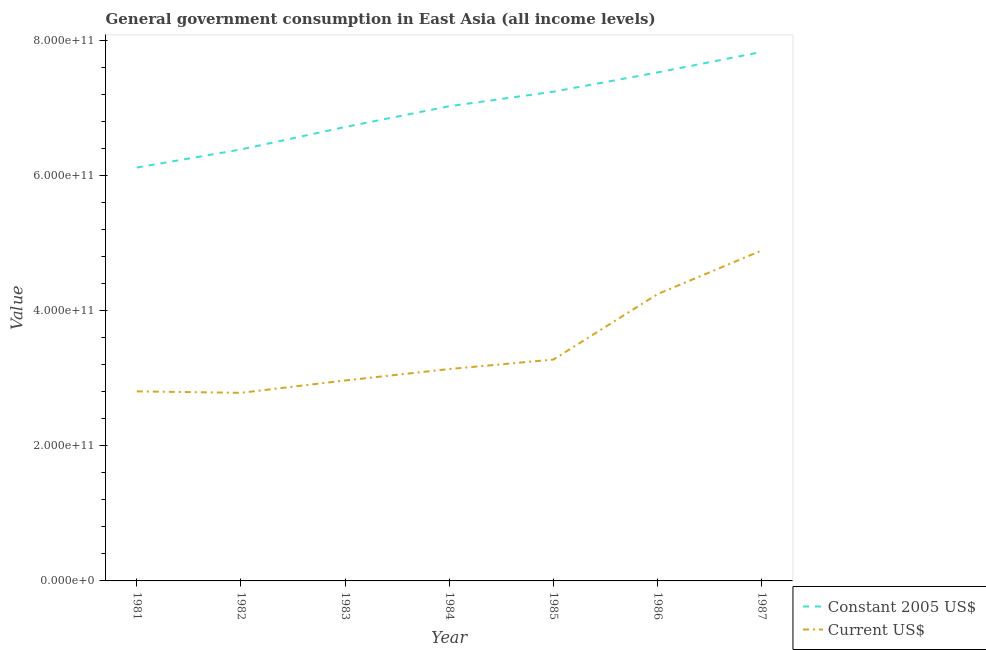How many different coloured lines are there?
Your response must be concise. 2. Does the line corresponding to value consumed in current us$ intersect with the line corresponding to value consumed in constant 2005 us$?
Keep it short and to the point. No. Is the number of lines equal to the number of legend labels?
Your response must be concise. Yes. What is the value consumed in current us$ in 1984?
Provide a short and direct response. 3.13e+11. Across all years, what is the maximum value consumed in current us$?
Offer a very short reply. 4.89e+11. Across all years, what is the minimum value consumed in constant 2005 us$?
Your answer should be very brief. 6.11e+11. What is the total value consumed in constant 2005 us$ in the graph?
Provide a succinct answer. 4.88e+12. What is the difference between the value consumed in current us$ in 1984 and that in 1986?
Your response must be concise. -1.11e+11. What is the difference between the value consumed in current us$ in 1985 and the value consumed in constant 2005 us$ in 1984?
Provide a succinct answer. -3.75e+11. What is the average value consumed in constant 2005 us$ per year?
Your response must be concise. 6.97e+11. In the year 1985, what is the difference between the value consumed in constant 2005 us$ and value consumed in current us$?
Your response must be concise. 3.96e+11. In how many years, is the value consumed in constant 2005 us$ greater than 240000000000?
Offer a very short reply. 7. What is the ratio of the value consumed in current us$ in 1985 to that in 1986?
Offer a very short reply. 0.77. Is the difference between the value consumed in constant 2005 us$ in 1985 and 1986 greater than the difference between the value consumed in current us$ in 1985 and 1986?
Make the answer very short. Yes. What is the difference between the highest and the second highest value consumed in current us$?
Offer a terse response. 6.45e+1. What is the difference between the highest and the lowest value consumed in current us$?
Offer a very short reply. 2.11e+11. In how many years, is the value consumed in current us$ greater than the average value consumed in current us$ taken over all years?
Your answer should be very brief. 2. Is the sum of the value consumed in constant 2005 us$ in 1984 and 1985 greater than the maximum value consumed in current us$ across all years?
Offer a very short reply. Yes. How many years are there in the graph?
Your response must be concise. 7. What is the difference between two consecutive major ticks on the Y-axis?
Make the answer very short. 2.00e+11. Are the values on the major ticks of Y-axis written in scientific E-notation?
Offer a very short reply. Yes. Does the graph contain grids?
Offer a very short reply. No. Where does the legend appear in the graph?
Your answer should be compact. Bottom right. What is the title of the graph?
Keep it short and to the point. General government consumption in East Asia (all income levels). What is the label or title of the Y-axis?
Your response must be concise. Value. What is the Value of Constant 2005 US$ in 1981?
Give a very brief answer. 6.11e+11. What is the Value in Current US$ in 1981?
Your response must be concise. 2.80e+11. What is the Value in Constant 2005 US$ in 1982?
Ensure brevity in your answer.  6.38e+11. What is the Value of Current US$ in 1982?
Give a very brief answer. 2.78e+11. What is the Value of Constant 2005 US$ in 1983?
Ensure brevity in your answer.  6.71e+11. What is the Value of Current US$ in 1983?
Provide a succinct answer. 2.96e+11. What is the Value of Constant 2005 US$ in 1984?
Your response must be concise. 7.02e+11. What is the Value in Current US$ in 1984?
Provide a short and direct response. 3.13e+11. What is the Value of Constant 2005 US$ in 1985?
Offer a very short reply. 7.24e+11. What is the Value in Current US$ in 1985?
Make the answer very short. 3.27e+11. What is the Value in Constant 2005 US$ in 1986?
Provide a short and direct response. 7.52e+11. What is the Value of Current US$ in 1986?
Give a very brief answer. 4.24e+11. What is the Value of Constant 2005 US$ in 1987?
Your answer should be very brief. 7.83e+11. What is the Value in Current US$ in 1987?
Ensure brevity in your answer.  4.89e+11. Across all years, what is the maximum Value in Constant 2005 US$?
Provide a short and direct response. 7.83e+11. Across all years, what is the maximum Value of Current US$?
Provide a short and direct response. 4.89e+11. Across all years, what is the minimum Value of Constant 2005 US$?
Your answer should be very brief. 6.11e+11. Across all years, what is the minimum Value in Current US$?
Provide a succinct answer. 2.78e+11. What is the total Value in Constant 2005 US$ in the graph?
Your response must be concise. 4.88e+12. What is the total Value of Current US$ in the graph?
Give a very brief answer. 2.41e+12. What is the difference between the Value of Constant 2005 US$ in 1981 and that in 1982?
Offer a terse response. -2.68e+1. What is the difference between the Value of Current US$ in 1981 and that in 1982?
Provide a succinct answer. 2.12e+09. What is the difference between the Value in Constant 2005 US$ in 1981 and that in 1983?
Provide a short and direct response. -6.00e+1. What is the difference between the Value of Current US$ in 1981 and that in 1983?
Ensure brevity in your answer.  -1.61e+1. What is the difference between the Value of Constant 2005 US$ in 1981 and that in 1984?
Your answer should be very brief. -9.08e+1. What is the difference between the Value of Current US$ in 1981 and that in 1984?
Your response must be concise. -3.31e+1. What is the difference between the Value in Constant 2005 US$ in 1981 and that in 1985?
Keep it short and to the point. -1.12e+11. What is the difference between the Value in Current US$ in 1981 and that in 1985?
Offer a terse response. -4.70e+1. What is the difference between the Value in Constant 2005 US$ in 1981 and that in 1986?
Ensure brevity in your answer.  -1.41e+11. What is the difference between the Value of Current US$ in 1981 and that in 1986?
Your answer should be very brief. -1.44e+11. What is the difference between the Value in Constant 2005 US$ in 1981 and that in 1987?
Your answer should be compact. -1.71e+11. What is the difference between the Value of Current US$ in 1981 and that in 1987?
Offer a terse response. -2.08e+11. What is the difference between the Value of Constant 2005 US$ in 1982 and that in 1983?
Provide a short and direct response. -3.32e+1. What is the difference between the Value of Current US$ in 1982 and that in 1983?
Your response must be concise. -1.82e+1. What is the difference between the Value of Constant 2005 US$ in 1982 and that in 1984?
Offer a terse response. -6.40e+1. What is the difference between the Value of Current US$ in 1982 and that in 1984?
Offer a very short reply. -3.52e+1. What is the difference between the Value in Constant 2005 US$ in 1982 and that in 1985?
Offer a terse response. -8.54e+1. What is the difference between the Value in Current US$ in 1982 and that in 1985?
Offer a terse response. -4.92e+1. What is the difference between the Value of Constant 2005 US$ in 1982 and that in 1986?
Your response must be concise. -1.14e+11. What is the difference between the Value in Current US$ in 1982 and that in 1986?
Give a very brief answer. -1.46e+11. What is the difference between the Value in Constant 2005 US$ in 1982 and that in 1987?
Make the answer very short. -1.44e+11. What is the difference between the Value of Current US$ in 1982 and that in 1987?
Provide a succinct answer. -2.11e+11. What is the difference between the Value of Constant 2005 US$ in 1983 and that in 1984?
Your response must be concise. -3.08e+1. What is the difference between the Value of Current US$ in 1983 and that in 1984?
Make the answer very short. -1.70e+1. What is the difference between the Value in Constant 2005 US$ in 1983 and that in 1985?
Your response must be concise. -5.23e+1. What is the difference between the Value in Current US$ in 1983 and that in 1985?
Make the answer very short. -3.10e+1. What is the difference between the Value of Constant 2005 US$ in 1983 and that in 1986?
Offer a very short reply. -8.08e+1. What is the difference between the Value in Current US$ in 1983 and that in 1986?
Keep it short and to the point. -1.28e+11. What is the difference between the Value of Constant 2005 US$ in 1983 and that in 1987?
Your response must be concise. -1.11e+11. What is the difference between the Value in Current US$ in 1983 and that in 1987?
Your answer should be very brief. -1.92e+11. What is the difference between the Value in Constant 2005 US$ in 1984 and that in 1985?
Ensure brevity in your answer.  -2.15e+1. What is the difference between the Value in Current US$ in 1984 and that in 1985?
Your answer should be very brief. -1.40e+1. What is the difference between the Value in Constant 2005 US$ in 1984 and that in 1986?
Make the answer very short. -5.00e+1. What is the difference between the Value of Current US$ in 1984 and that in 1986?
Make the answer very short. -1.11e+11. What is the difference between the Value in Constant 2005 US$ in 1984 and that in 1987?
Ensure brevity in your answer.  -8.03e+1. What is the difference between the Value of Current US$ in 1984 and that in 1987?
Your response must be concise. -1.75e+11. What is the difference between the Value in Constant 2005 US$ in 1985 and that in 1986?
Provide a succinct answer. -2.85e+1. What is the difference between the Value in Current US$ in 1985 and that in 1986?
Your response must be concise. -9.68e+1. What is the difference between the Value in Constant 2005 US$ in 1985 and that in 1987?
Give a very brief answer. -5.88e+1. What is the difference between the Value of Current US$ in 1985 and that in 1987?
Your answer should be very brief. -1.61e+11. What is the difference between the Value in Constant 2005 US$ in 1986 and that in 1987?
Your answer should be very brief. -3.03e+1. What is the difference between the Value in Current US$ in 1986 and that in 1987?
Your answer should be very brief. -6.45e+1. What is the difference between the Value in Constant 2005 US$ in 1981 and the Value in Current US$ in 1982?
Offer a terse response. 3.33e+11. What is the difference between the Value of Constant 2005 US$ in 1981 and the Value of Current US$ in 1983?
Offer a very short reply. 3.15e+11. What is the difference between the Value in Constant 2005 US$ in 1981 and the Value in Current US$ in 1984?
Keep it short and to the point. 2.98e+11. What is the difference between the Value of Constant 2005 US$ in 1981 and the Value of Current US$ in 1985?
Offer a very short reply. 2.84e+11. What is the difference between the Value in Constant 2005 US$ in 1981 and the Value in Current US$ in 1986?
Give a very brief answer. 1.87e+11. What is the difference between the Value in Constant 2005 US$ in 1981 and the Value in Current US$ in 1987?
Your response must be concise. 1.23e+11. What is the difference between the Value in Constant 2005 US$ in 1982 and the Value in Current US$ in 1983?
Offer a very short reply. 3.42e+11. What is the difference between the Value of Constant 2005 US$ in 1982 and the Value of Current US$ in 1984?
Provide a succinct answer. 3.25e+11. What is the difference between the Value of Constant 2005 US$ in 1982 and the Value of Current US$ in 1985?
Keep it short and to the point. 3.11e+11. What is the difference between the Value in Constant 2005 US$ in 1982 and the Value in Current US$ in 1986?
Make the answer very short. 2.14e+11. What is the difference between the Value in Constant 2005 US$ in 1982 and the Value in Current US$ in 1987?
Your response must be concise. 1.49e+11. What is the difference between the Value of Constant 2005 US$ in 1983 and the Value of Current US$ in 1984?
Offer a very short reply. 3.58e+11. What is the difference between the Value of Constant 2005 US$ in 1983 and the Value of Current US$ in 1985?
Offer a terse response. 3.44e+11. What is the difference between the Value in Constant 2005 US$ in 1983 and the Value in Current US$ in 1986?
Keep it short and to the point. 2.47e+11. What is the difference between the Value in Constant 2005 US$ in 1983 and the Value in Current US$ in 1987?
Offer a very short reply. 1.83e+11. What is the difference between the Value in Constant 2005 US$ in 1984 and the Value in Current US$ in 1985?
Your answer should be very brief. 3.75e+11. What is the difference between the Value of Constant 2005 US$ in 1984 and the Value of Current US$ in 1986?
Give a very brief answer. 2.78e+11. What is the difference between the Value in Constant 2005 US$ in 1984 and the Value in Current US$ in 1987?
Keep it short and to the point. 2.13e+11. What is the difference between the Value of Constant 2005 US$ in 1985 and the Value of Current US$ in 1986?
Your answer should be very brief. 2.99e+11. What is the difference between the Value in Constant 2005 US$ in 1985 and the Value in Current US$ in 1987?
Make the answer very short. 2.35e+11. What is the difference between the Value in Constant 2005 US$ in 1986 and the Value in Current US$ in 1987?
Your answer should be very brief. 2.63e+11. What is the average Value of Constant 2005 US$ per year?
Offer a terse response. 6.97e+11. What is the average Value in Current US$ per year?
Offer a terse response. 3.44e+11. In the year 1981, what is the difference between the Value of Constant 2005 US$ and Value of Current US$?
Give a very brief answer. 3.31e+11. In the year 1982, what is the difference between the Value of Constant 2005 US$ and Value of Current US$?
Your answer should be compact. 3.60e+11. In the year 1983, what is the difference between the Value of Constant 2005 US$ and Value of Current US$?
Your response must be concise. 3.75e+11. In the year 1984, what is the difference between the Value of Constant 2005 US$ and Value of Current US$?
Your answer should be compact. 3.89e+11. In the year 1985, what is the difference between the Value of Constant 2005 US$ and Value of Current US$?
Keep it short and to the point. 3.96e+11. In the year 1986, what is the difference between the Value of Constant 2005 US$ and Value of Current US$?
Make the answer very short. 3.28e+11. In the year 1987, what is the difference between the Value of Constant 2005 US$ and Value of Current US$?
Keep it short and to the point. 2.94e+11. What is the ratio of the Value in Constant 2005 US$ in 1981 to that in 1982?
Your answer should be compact. 0.96. What is the ratio of the Value of Current US$ in 1981 to that in 1982?
Keep it short and to the point. 1.01. What is the ratio of the Value in Constant 2005 US$ in 1981 to that in 1983?
Offer a terse response. 0.91. What is the ratio of the Value in Current US$ in 1981 to that in 1983?
Offer a very short reply. 0.95. What is the ratio of the Value in Constant 2005 US$ in 1981 to that in 1984?
Offer a terse response. 0.87. What is the ratio of the Value of Current US$ in 1981 to that in 1984?
Provide a short and direct response. 0.89. What is the ratio of the Value in Constant 2005 US$ in 1981 to that in 1985?
Your response must be concise. 0.84. What is the ratio of the Value of Current US$ in 1981 to that in 1985?
Provide a short and direct response. 0.86. What is the ratio of the Value in Constant 2005 US$ in 1981 to that in 1986?
Your answer should be compact. 0.81. What is the ratio of the Value in Current US$ in 1981 to that in 1986?
Your answer should be compact. 0.66. What is the ratio of the Value in Constant 2005 US$ in 1981 to that in 1987?
Offer a terse response. 0.78. What is the ratio of the Value in Current US$ in 1981 to that in 1987?
Give a very brief answer. 0.57. What is the ratio of the Value in Constant 2005 US$ in 1982 to that in 1983?
Ensure brevity in your answer.  0.95. What is the ratio of the Value of Current US$ in 1982 to that in 1983?
Your answer should be very brief. 0.94. What is the ratio of the Value of Constant 2005 US$ in 1982 to that in 1984?
Make the answer very short. 0.91. What is the ratio of the Value of Current US$ in 1982 to that in 1984?
Your response must be concise. 0.89. What is the ratio of the Value in Constant 2005 US$ in 1982 to that in 1985?
Ensure brevity in your answer.  0.88. What is the ratio of the Value of Current US$ in 1982 to that in 1985?
Offer a terse response. 0.85. What is the ratio of the Value in Constant 2005 US$ in 1982 to that in 1986?
Your answer should be very brief. 0.85. What is the ratio of the Value of Current US$ in 1982 to that in 1986?
Provide a succinct answer. 0.66. What is the ratio of the Value of Constant 2005 US$ in 1982 to that in 1987?
Offer a very short reply. 0.82. What is the ratio of the Value in Current US$ in 1982 to that in 1987?
Offer a terse response. 0.57. What is the ratio of the Value in Constant 2005 US$ in 1983 to that in 1984?
Offer a terse response. 0.96. What is the ratio of the Value of Current US$ in 1983 to that in 1984?
Give a very brief answer. 0.95. What is the ratio of the Value of Constant 2005 US$ in 1983 to that in 1985?
Provide a succinct answer. 0.93. What is the ratio of the Value of Current US$ in 1983 to that in 1985?
Offer a terse response. 0.91. What is the ratio of the Value in Constant 2005 US$ in 1983 to that in 1986?
Give a very brief answer. 0.89. What is the ratio of the Value in Current US$ in 1983 to that in 1986?
Offer a terse response. 0.7. What is the ratio of the Value in Constant 2005 US$ in 1983 to that in 1987?
Keep it short and to the point. 0.86. What is the ratio of the Value of Current US$ in 1983 to that in 1987?
Give a very brief answer. 0.61. What is the ratio of the Value of Constant 2005 US$ in 1984 to that in 1985?
Offer a terse response. 0.97. What is the ratio of the Value of Current US$ in 1984 to that in 1985?
Keep it short and to the point. 0.96. What is the ratio of the Value of Constant 2005 US$ in 1984 to that in 1986?
Your answer should be very brief. 0.93. What is the ratio of the Value of Current US$ in 1984 to that in 1986?
Keep it short and to the point. 0.74. What is the ratio of the Value in Constant 2005 US$ in 1984 to that in 1987?
Your answer should be very brief. 0.9. What is the ratio of the Value in Current US$ in 1984 to that in 1987?
Your response must be concise. 0.64. What is the ratio of the Value in Constant 2005 US$ in 1985 to that in 1986?
Provide a short and direct response. 0.96. What is the ratio of the Value in Current US$ in 1985 to that in 1986?
Provide a short and direct response. 0.77. What is the ratio of the Value of Constant 2005 US$ in 1985 to that in 1987?
Provide a short and direct response. 0.92. What is the ratio of the Value in Current US$ in 1985 to that in 1987?
Provide a short and direct response. 0.67. What is the ratio of the Value of Constant 2005 US$ in 1986 to that in 1987?
Your answer should be compact. 0.96. What is the ratio of the Value in Current US$ in 1986 to that in 1987?
Your answer should be compact. 0.87. What is the difference between the highest and the second highest Value in Constant 2005 US$?
Your answer should be very brief. 3.03e+1. What is the difference between the highest and the second highest Value of Current US$?
Your response must be concise. 6.45e+1. What is the difference between the highest and the lowest Value in Constant 2005 US$?
Your response must be concise. 1.71e+11. What is the difference between the highest and the lowest Value in Current US$?
Offer a very short reply. 2.11e+11. 